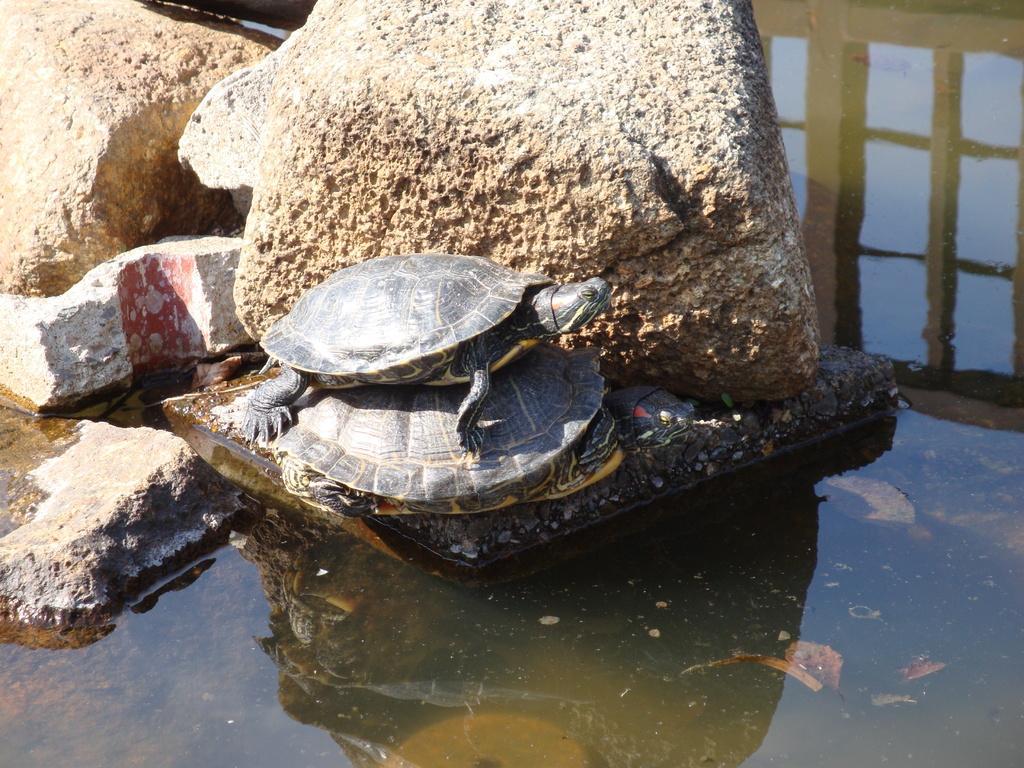Please provide a concise description of this image. In the center of the image we can see turtles. At the bottom there is water. In the background there are rocks. 